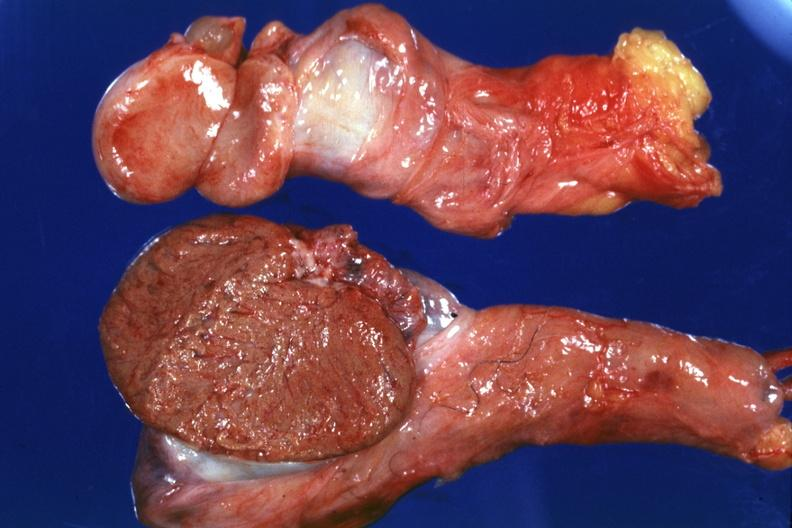what have no history at this time?
Answer the question using a single word or phrase. Cut surface both testicles on normal and one quite small typical probably due to mumps 